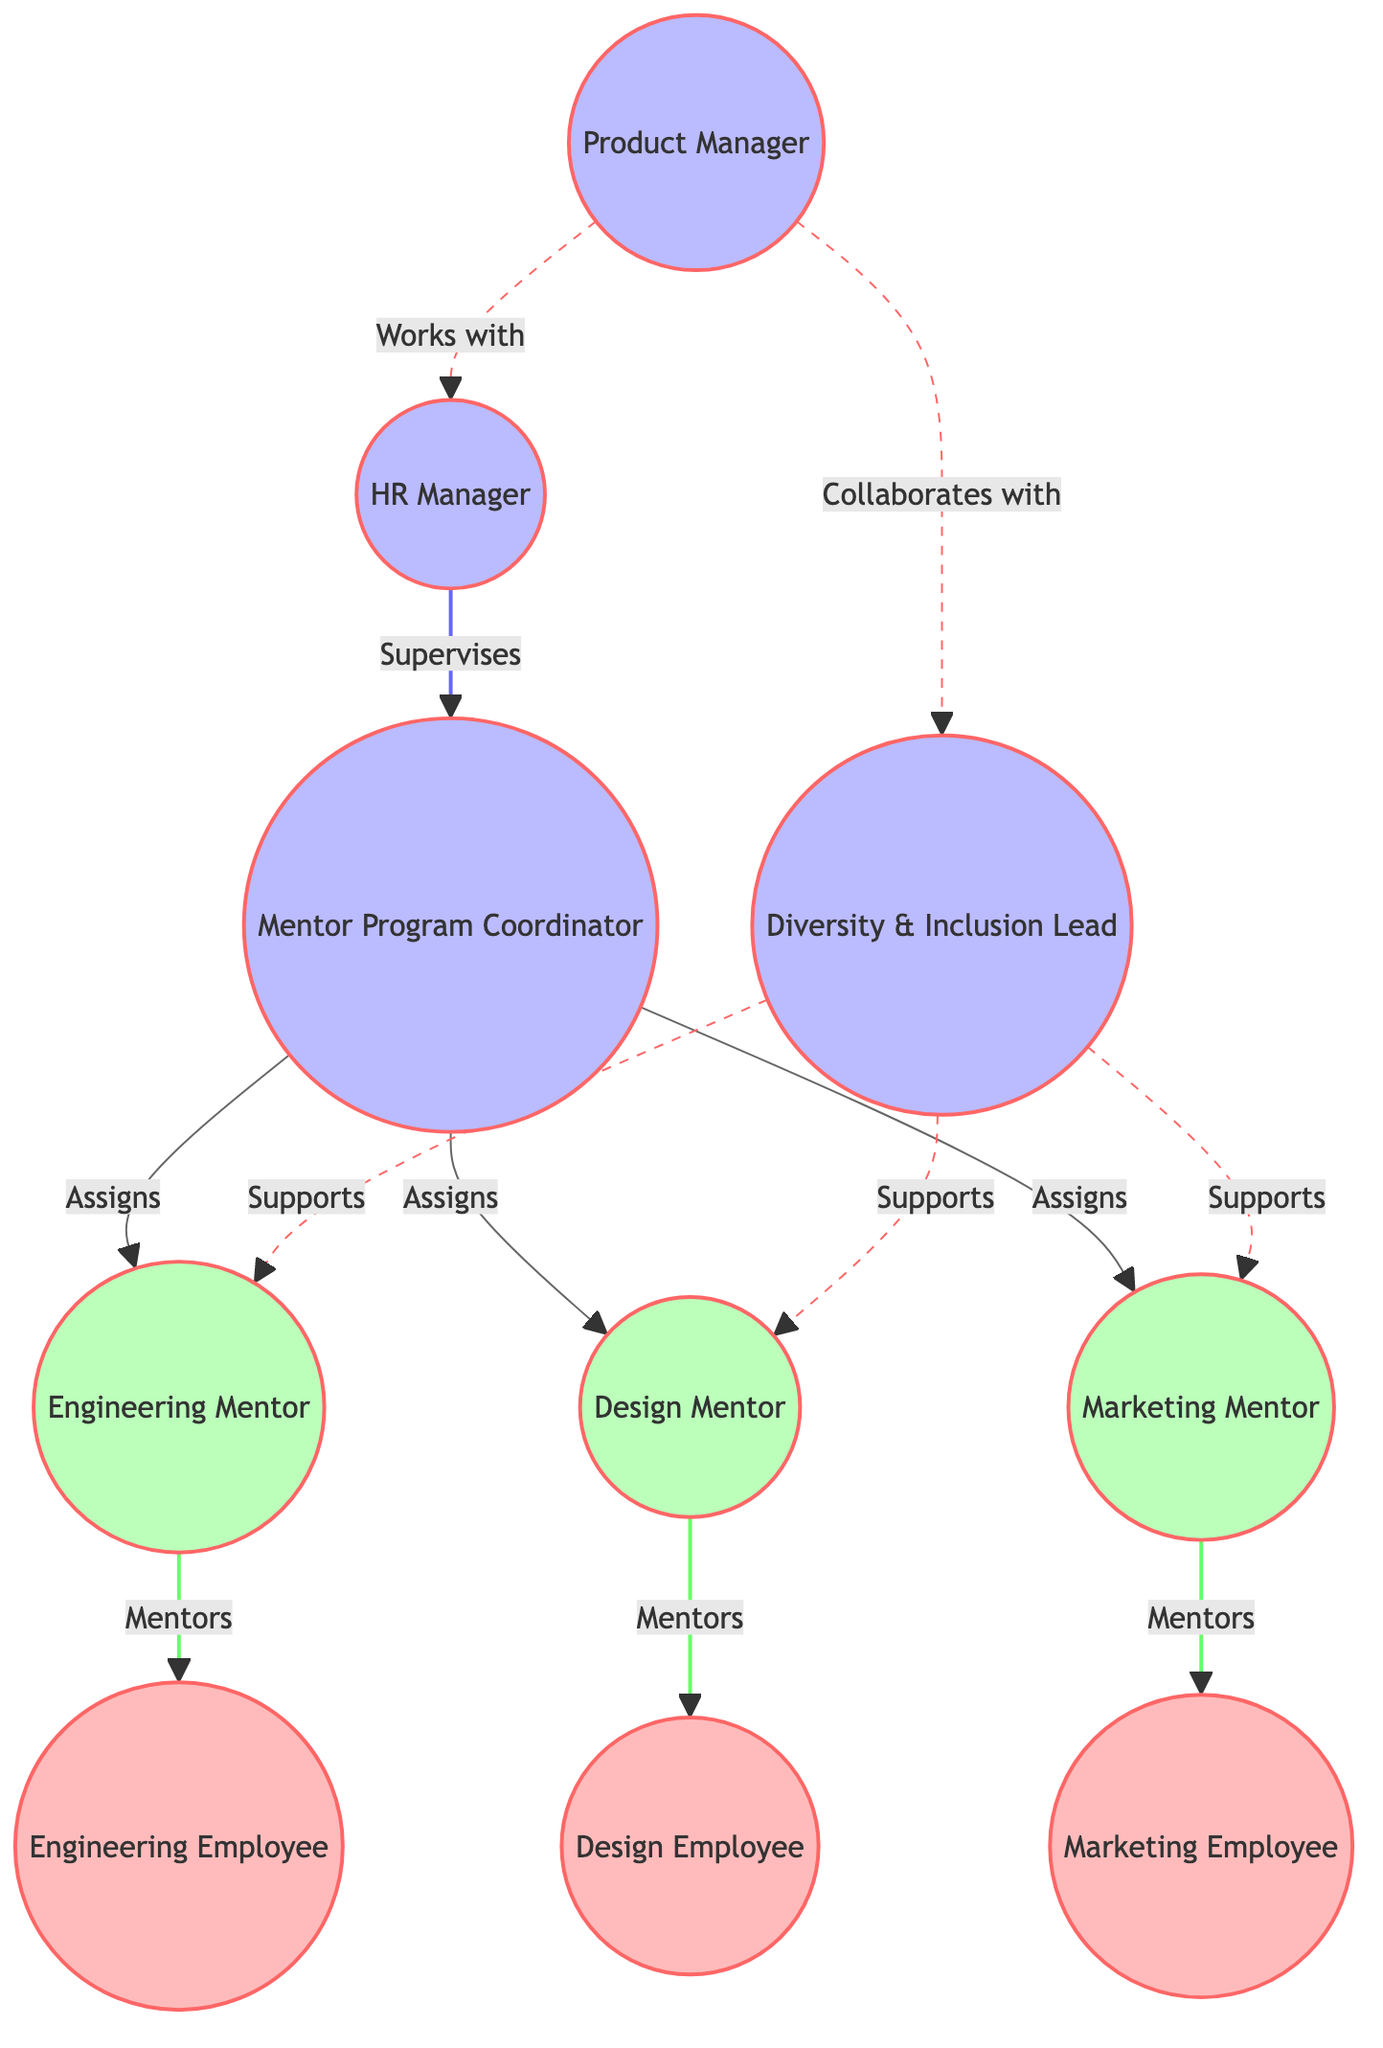What role does the HR Manager supervise? The HR Manager supervises the Mentor Program Coordinator as indicated by the type of edge labeled "Supervises."
Answer: Mentor Program Coordinator How many mentors are assigned by the Mentor Program Coordinator? The Mentor Program Coordinator has three edges leading to the mentors, indicating that they assign three roles: Engineering Mentor, Design Mentor, and Marketing Mentor.
Answer: 3 Which node collaborates with the Diversity & Inclusion Lead? The Product Manager collaborates with the Diversity & Inclusion Lead, as shown by the edge labeled "Collaborates with."
Answer: Product Manager What type of relationship do the Engineering Mentor and Engineering Employee have? The Engineering Mentor has a direct edge to the Engineering Employee, labeled "Mentors," indicating a mentorship relationship.
Answer: Mentorship How many total nodes are present in the diagram? The diagram has a total of 10 unique nodes as listed, including roles such as Product Manager, HR Manager, and mentors.
Answer: 10 What support does the Diversity & Inclusion Lead provide? The Diversity & Inclusion Lead supports all three mentors: Engineering Mentor, Design Mentor, and Marketing Mentor, as shown by the edges labeled "Supports."
Answer: Supports Which mentor type is assigned to the Design Employee? The Design Employee is directly mentored by the Design Mentor, indicated by the edge labeled "Mentors."
Answer: Design Mentor What is the connection type between the Product Manager and HR Manager? The connection type between the Product Manager and HR Manager is labeled as "Works with," indicating a collaboration relationship.
Answer: Works with Which mentor does the Diversity & Inclusion Lead NOT support? The Diversity & Inclusion Lead supports Engineering Mentor, Design Mentor, and Marketing Mentor, but there is no support mentioned for any others. Thus, it indicates full coverage of the assigned mentors in the diagram.
Answer: None 